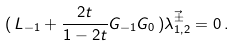<formula> <loc_0><loc_0><loc_500><loc_500>( \, L _ { - 1 } + \frac { 2 t } { 1 - 2 t } G _ { - 1 } G _ { 0 } \, ) \vec { \lambda _ { 1 , 2 } ^ { \pm } } = 0 \, .</formula> 